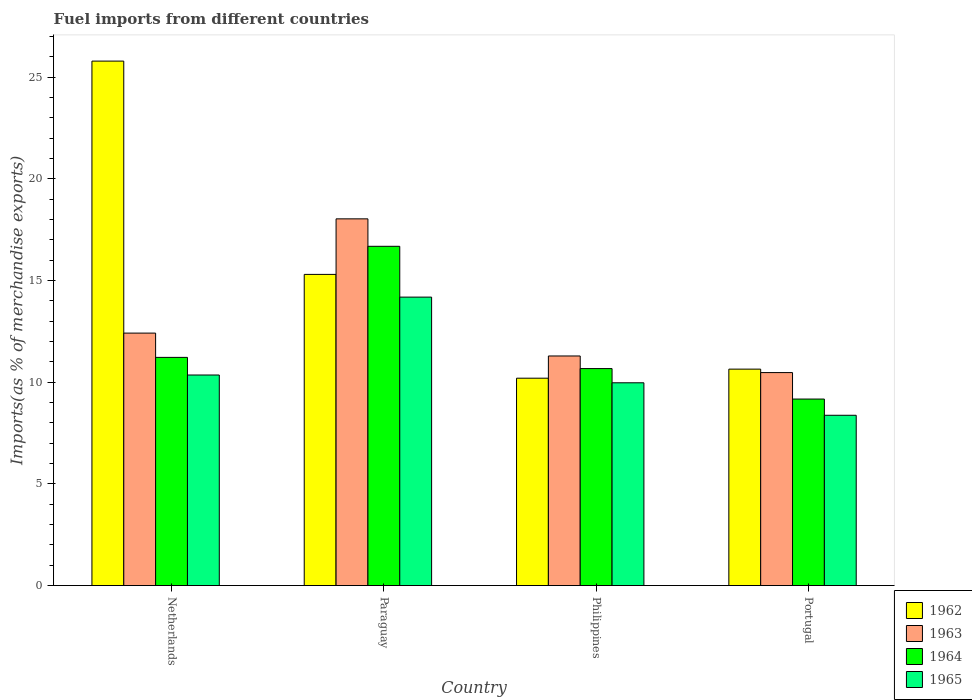How many different coloured bars are there?
Provide a succinct answer. 4. Are the number of bars on each tick of the X-axis equal?
Ensure brevity in your answer.  Yes. How many bars are there on the 3rd tick from the left?
Your answer should be very brief. 4. How many bars are there on the 1st tick from the right?
Offer a very short reply. 4. What is the label of the 4th group of bars from the left?
Make the answer very short. Portugal. What is the percentage of imports to different countries in 1965 in Paraguay?
Give a very brief answer. 14.18. Across all countries, what is the maximum percentage of imports to different countries in 1964?
Your answer should be very brief. 16.68. Across all countries, what is the minimum percentage of imports to different countries in 1963?
Offer a very short reply. 10.47. In which country was the percentage of imports to different countries in 1965 maximum?
Your response must be concise. Paraguay. What is the total percentage of imports to different countries in 1962 in the graph?
Offer a terse response. 61.92. What is the difference between the percentage of imports to different countries in 1962 in Philippines and that in Portugal?
Provide a succinct answer. -0.45. What is the difference between the percentage of imports to different countries in 1964 in Netherlands and the percentage of imports to different countries in 1962 in Portugal?
Ensure brevity in your answer.  0.58. What is the average percentage of imports to different countries in 1964 per country?
Offer a terse response. 11.93. What is the difference between the percentage of imports to different countries of/in 1962 and percentage of imports to different countries of/in 1963 in Philippines?
Your answer should be very brief. -1.09. What is the ratio of the percentage of imports to different countries in 1965 in Paraguay to that in Philippines?
Give a very brief answer. 1.42. Is the difference between the percentage of imports to different countries in 1962 in Philippines and Portugal greater than the difference between the percentage of imports to different countries in 1963 in Philippines and Portugal?
Give a very brief answer. No. What is the difference between the highest and the second highest percentage of imports to different countries in 1964?
Provide a succinct answer. 6.01. What is the difference between the highest and the lowest percentage of imports to different countries in 1963?
Offer a very short reply. 7.56. In how many countries, is the percentage of imports to different countries in 1963 greater than the average percentage of imports to different countries in 1963 taken over all countries?
Make the answer very short. 1. Is it the case that in every country, the sum of the percentage of imports to different countries in 1963 and percentage of imports to different countries in 1964 is greater than the sum of percentage of imports to different countries in 1962 and percentage of imports to different countries in 1965?
Give a very brief answer. No. What does the 3rd bar from the left in Paraguay represents?
Your response must be concise. 1964. Is it the case that in every country, the sum of the percentage of imports to different countries in 1962 and percentage of imports to different countries in 1964 is greater than the percentage of imports to different countries in 1963?
Give a very brief answer. Yes. How many bars are there?
Give a very brief answer. 16. How many countries are there in the graph?
Offer a terse response. 4. What is the difference between two consecutive major ticks on the Y-axis?
Ensure brevity in your answer.  5. Where does the legend appear in the graph?
Make the answer very short. Bottom right. How are the legend labels stacked?
Ensure brevity in your answer.  Vertical. What is the title of the graph?
Your response must be concise. Fuel imports from different countries. What is the label or title of the Y-axis?
Your answer should be very brief. Imports(as % of merchandise exports). What is the Imports(as % of merchandise exports) of 1962 in Netherlands?
Your answer should be compact. 25.79. What is the Imports(as % of merchandise exports) in 1963 in Netherlands?
Your response must be concise. 12.41. What is the Imports(as % of merchandise exports) of 1964 in Netherlands?
Give a very brief answer. 11.22. What is the Imports(as % of merchandise exports) in 1965 in Netherlands?
Keep it short and to the point. 10.35. What is the Imports(as % of merchandise exports) of 1962 in Paraguay?
Make the answer very short. 15.3. What is the Imports(as % of merchandise exports) of 1963 in Paraguay?
Keep it short and to the point. 18.03. What is the Imports(as % of merchandise exports) in 1964 in Paraguay?
Your answer should be very brief. 16.68. What is the Imports(as % of merchandise exports) of 1965 in Paraguay?
Offer a terse response. 14.18. What is the Imports(as % of merchandise exports) in 1962 in Philippines?
Your response must be concise. 10.2. What is the Imports(as % of merchandise exports) of 1963 in Philippines?
Give a very brief answer. 11.29. What is the Imports(as % of merchandise exports) in 1964 in Philippines?
Provide a short and direct response. 10.67. What is the Imports(as % of merchandise exports) in 1965 in Philippines?
Your answer should be very brief. 9.97. What is the Imports(as % of merchandise exports) of 1962 in Portugal?
Your answer should be very brief. 10.64. What is the Imports(as % of merchandise exports) of 1963 in Portugal?
Provide a short and direct response. 10.47. What is the Imports(as % of merchandise exports) of 1964 in Portugal?
Ensure brevity in your answer.  9.17. What is the Imports(as % of merchandise exports) in 1965 in Portugal?
Your answer should be very brief. 8.37. Across all countries, what is the maximum Imports(as % of merchandise exports) of 1962?
Keep it short and to the point. 25.79. Across all countries, what is the maximum Imports(as % of merchandise exports) of 1963?
Make the answer very short. 18.03. Across all countries, what is the maximum Imports(as % of merchandise exports) of 1964?
Offer a very short reply. 16.68. Across all countries, what is the maximum Imports(as % of merchandise exports) in 1965?
Provide a short and direct response. 14.18. Across all countries, what is the minimum Imports(as % of merchandise exports) of 1962?
Your answer should be very brief. 10.2. Across all countries, what is the minimum Imports(as % of merchandise exports) of 1963?
Your response must be concise. 10.47. Across all countries, what is the minimum Imports(as % of merchandise exports) of 1964?
Provide a succinct answer. 9.17. Across all countries, what is the minimum Imports(as % of merchandise exports) in 1965?
Keep it short and to the point. 8.37. What is the total Imports(as % of merchandise exports) of 1962 in the graph?
Provide a succinct answer. 61.92. What is the total Imports(as % of merchandise exports) in 1963 in the graph?
Provide a succinct answer. 52.2. What is the total Imports(as % of merchandise exports) of 1964 in the graph?
Keep it short and to the point. 47.74. What is the total Imports(as % of merchandise exports) of 1965 in the graph?
Make the answer very short. 42.88. What is the difference between the Imports(as % of merchandise exports) in 1962 in Netherlands and that in Paraguay?
Ensure brevity in your answer.  10.49. What is the difference between the Imports(as % of merchandise exports) in 1963 in Netherlands and that in Paraguay?
Offer a terse response. -5.62. What is the difference between the Imports(as % of merchandise exports) in 1964 in Netherlands and that in Paraguay?
Provide a succinct answer. -5.46. What is the difference between the Imports(as % of merchandise exports) in 1965 in Netherlands and that in Paraguay?
Provide a short and direct response. -3.83. What is the difference between the Imports(as % of merchandise exports) of 1962 in Netherlands and that in Philippines?
Provide a short and direct response. 15.59. What is the difference between the Imports(as % of merchandise exports) of 1963 in Netherlands and that in Philippines?
Ensure brevity in your answer.  1.12. What is the difference between the Imports(as % of merchandise exports) of 1964 in Netherlands and that in Philippines?
Provide a short and direct response. 0.55. What is the difference between the Imports(as % of merchandise exports) of 1965 in Netherlands and that in Philippines?
Offer a terse response. 0.38. What is the difference between the Imports(as % of merchandise exports) in 1962 in Netherlands and that in Portugal?
Offer a very short reply. 15.15. What is the difference between the Imports(as % of merchandise exports) in 1963 in Netherlands and that in Portugal?
Keep it short and to the point. 1.94. What is the difference between the Imports(as % of merchandise exports) of 1964 in Netherlands and that in Portugal?
Ensure brevity in your answer.  2.05. What is the difference between the Imports(as % of merchandise exports) of 1965 in Netherlands and that in Portugal?
Keep it short and to the point. 1.98. What is the difference between the Imports(as % of merchandise exports) of 1962 in Paraguay and that in Philippines?
Provide a short and direct response. 5.1. What is the difference between the Imports(as % of merchandise exports) of 1963 in Paraguay and that in Philippines?
Your answer should be compact. 6.74. What is the difference between the Imports(as % of merchandise exports) of 1964 in Paraguay and that in Philippines?
Provide a succinct answer. 6.01. What is the difference between the Imports(as % of merchandise exports) of 1965 in Paraguay and that in Philippines?
Provide a short and direct response. 4.21. What is the difference between the Imports(as % of merchandise exports) of 1962 in Paraguay and that in Portugal?
Your answer should be very brief. 4.66. What is the difference between the Imports(as % of merchandise exports) in 1963 in Paraguay and that in Portugal?
Keep it short and to the point. 7.56. What is the difference between the Imports(as % of merchandise exports) of 1964 in Paraguay and that in Portugal?
Make the answer very short. 7.51. What is the difference between the Imports(as % of merchandise exports) in 1965 in Paraguay and that in Portugal?
Keep it short and to the point. 5.81. What is the difference between the Imports(as % of merchandise exports) in 1962 in Philippines and that in Portugal?
Provide a succinct answer. -0.45. What is the difference between the Imports(as % of merchandise exports) in 1963 in Philippines and that in Portugal?
Your response must be concise. 0.82. What is the difference between the Imports(as % of merchandise exports) in 1964 in Philippines and that in Portugal?
Keep it short and to the point. 1.5. What is the difference between the Imports(as % of merchandise exports) of 1965 in Philippines and that in Portugal?
Ensure brevity in your answer.  1.6. What is the difference between the Imports(as % of merchandise exports) of 1962 in Netherlands and the Imports(as % of merchandise exports) of 1963 in Paraguay?
Make the answer very short. 7.76. What is the difference between the Imports(as % of merchandise exports) in 1962 in Netherlands and the Imports(as % of merchandise exports) in 1964 in Paraguay?
Make the answer very short. 9.11. What is the difference between the Imports(as % of merchandise exports) in 1962 in Netherlands and the Imports(as % of merchandise exports) in 1965 in Paraguay?
Your answer should be very brief. 11.6. What is the difference between the Imports(as % of merchandise exports) of 1963 in Netherlands and the Imports(as % of merchandise exports) of 1964 in Paraguay?
Your answer should be compact. -4.27. What is the difference between the Imports(as % of merchandise exports) of 1963 in Netherlands and the Imports(as % of merchandise exports) of 1965 in Paraguay?
Your response must be concise. -1.77. What is the difference between the Imports(as % of merchandise exports) of 1964 in Netherlands and the Imports(as % of merchandise exports) of 1965 in Paraguay?
Provide a short and direct response. -2.96. What is the difference between the Imports(as % of merchandise exports) in 1962 in Netherlands and the Imports(as % of merchandise exports) in 1963 in Philippines?
Your response must be concise. 14.5. What is the difference between the Imports(as % of merchandise exports) in 1962 in Netherlands and the Imports(as % of merchandise exports) in 1964 in Philippines?
Keep it short and to the point. 15.12. What is the difference between the Imports(as % of merchandise exports) of 1962 in Netherlands and the Imports(as % of merchandise exports) of 1965 in Philippines?
Make the answer very short. 15.82. What is the difference between the Imports(as % of merchandise exports) of 1963 in Netherlands and the Imports(as % of merchandise exports) of 1964 in Philippines?
Your response must be concise. 1.74. What is the difference between the Imports(as % of merchandise exports) of 1963 in Netherlands and the Imports(as % of merchandise exports) of 1965 in Philippines?
Make the answer very short. 2.44. What is the difference between the Imports(as % of merchandise exports) in 1964 in Netherlands and the Imports(as % of merchandise exports) in 1965 in Philippines?
Make the answer very short. 1.25. What is the difference between the Imports(as % of merchandise exports) of 1962 in Netherlands and the Imports(as % of merchandise exports) of 1963 in Portugal?
Ensure brevity in your answer.  15.32. What is the difference between the Imports(as % of merchandise exports) of 1962 in Netherlands and the Imports(as % of merchandise exports) of 1964 in Portugal?
Offer a very short reply. 16.62. What is the difference between the Imports(as % of merchandise exports) of 1962 in Netherlands and the Imports(as % of merchandise exports) of 1965 in Portugal?
Your answer should be compact. 17.41. What is the difference between the Imports(as % of merchandise exports) of 1963 in Netherlands and the Imports(as % of merchandise exports) of 1964 in Portugal?
Your response must be concise. 3.24. What is the difference between the Imports(as % of merchandise exports) of 1963 in Netherlands and the Imports(as % of merchandise exports) of 1965 in Portugal?
Your response must be concise. 4.04. What is the difference between the Imports(as % of merchandise exports) in 1964 in Netherlands and the Imports(as % of merchandise exports) in 1965 in Portugal?
Your answer should be compact. 2.85. What is the difference between the Imports(as % of merchandise exports) of 1962 in Paraguay and the Imports(as % of merchandise exports) of 1963 in Philippines?
Keep it short and to the point. 4.01. What is the difference between the Imports(as % of merchandise exports) in 1962 in Paraguay and the Imports(as % of merchandise exports) in 1964 in Philippines?
Make the answer very short. 4.63. What is the difference between the Imports(as % of merchandise exports) in 1962 in Paraguay and the Imports(as % of merchandise exports) in 1965 in Philippines?
Your answer should be very brief. 5.33. What is the difference between the Imports(as % of merchandise exports) in 1963 in Paraguay and the Imports(as % of merchandise exports) in 1964 in Philippines?
Your response must be concise. 7.36. What is the difference between the Imports(as % of merchandise exports) in 1963 in Paraguay and the Imports(as % of merchandise exports) in 1965 in Philippines?
Keep it short and to the point. 8.06. What is the difference between the Imports(as % of merchandise exports) of 1964 in Paraguay and the Imports(as % of merchandise exports) of 1965 in Philippines?
Give a very brief answer. 6.71. What is the difference between the Imports(as % of merchandise exports) of 1962 in Paraguay and the Imports(as % of merchandise exports) of 1963 in Portugal?
Your answer should be compact. 4.83. What is the difference between the Imports(as % of merchandise exports) of 1962 in Paraguay and the Imports(as % of merchandise exports) of 1964 in Portugal?
Offer a terse response. 6.13. What is the difference between the Imports(as % of merchandise exports) in 1962 in Paraguay and the Imports(as % of merchandise exports) in 1965 in Portugal?
Your response must be concise. 6.93. What is the difference between the Imports(as % of merchandise exports) of 1963 in Paraguay and the Imports(as % of merchandise exports) of 1964 in Portugal?
Keep it short and to the point. 8.86. What is the difference between the Imports(as % of merchandise exports) of 1963 in Paraguay and the Imports(as % of merchandise exports) of 1965 in Portugal?
Offer a very short reply. 9.66. What is the difference between the Imports(as % of merchandise exports) in 1964 in Paraguay and the Imports(as % of merchandise exports) in 1965 in Portugal?
Provide a short and direct response. 8.31. What is the difference between the Imports(as % of merchandise exports) of 1962 in Philippines and the Imports(as % of merchandise exports) of 1963 in Portugal?
Your response must be concise. -0.28. What is the difference between the Imports(as % of merchandise exports) in 1962 in Philippines and the Imports(as % of merchandise exports) in 1964 in Portugal?
Provide a succinct answer. 1.03. What is the difference between the Imports(as % of merchandise exports) of 1962 in Philippines and the Imports(as % of merchandise exports) of 1965 in Portugal?
Provide a short and direct response. 1.82. What is the difference between the Imports(as % of merchandise exports) in 1963 in Philippines and the Imports(as % of merchandise exports) in 1964 in Portugal?
Offer a terse response. 2.12. What is the difference between the Imports(as % of merchandise exports) in 1963 in Philippines and the Imports(as % of merchandise exports) in 1965 in Portugal?
Your response must be concise. 2.92. What is the difference between the Imports(as % of merchandise exports) in 1964 in Philippines and the Imports(as % of merchandise exports) in 1965 in Portugal?
Your response must be concise. 2.3. What is the average Imports(as % of merchandise exports) of 1962 per country?
Provide a succinct answer. 15.48. What is the average Imports(as % of merchandise exports) in 1963 per country?
Provide a short and direct response. 13.05. What is the average Imports(as % of merchandise exports) of 1964 per country?
Your answer should be compact. 11.94. What is the average Imports(as % of merchandise exports) of 1965 per country?
Provide a short and direct response. 10.72. What is the difference between the Imports(as % of merchandise exports) in 1962 and Imports(as % of merchandise exports) in 1963 in Netherlands?
Ensure brevity in your answer.  13.37. What is the difference between the Imports(as % of merchandise exports) in 1962 and Imports(as % of merchandise exports) in 1964 in Netherlands?
Provide a succinct answer. 14.57. What is the difference between the Imports(as % of merchandise exports) of 1962 and Imports(as % of merchandise exports) of 1965 in Netherlands?
Offer a very short reply. 15.43. What is the difference between the Imports(as % of merchandise exports) in 1963 and Imports(as % of merchandise exports) in 1964 in Netherlands?
Provide a succinct answer. 1.19. What is the difference between the Imports(as % of merchandise exports) in 1963 and Imports(as % of merchandise exports) in 1965 in Netherlands?
Provide a succinct answer. 2.06. What is the difference between the Imports(as % of merchandise exports) in 1964 and Imports(as % of merchandise exports) in 1965 in Netherlands?
Your answer should be compact. 0.87. What is the difference between the Imports(as % of merchandise exports) in 1962 and Imports(as % of merchandise exports) in 1963 in Paraguay?
Provide a short and direct response. -2.73. What is the difference between the Imports(as % of merchandise exports) of 1962 and Imports(as % of merchandise exports) of 1964 in Paraguay?
Offer a very short reply. -1.38. What is the difference between the Imports(as % of merchandise exports) of 1962 and Imports(as % of merchandise exports) of 1965 in Paraguay?
Your response must be concise. 1.12. What is the difference between the Imports(as % of merchandise exports) of 1963 and Imports(as % of merchandise exports) of 1964 in Paraguay?
Your answer should be very brief. 1.35. What is the difference between the Imports(as % of merchandise exports) of 1963 and Imports(as % of merchandise exports) of 1965 in Paraguay?
Ensure brevity in your answer.  3.85. What is the difference between the Imports(as % of merchandise exports) of 1964 and Imports(as % of merchandise exports) of 1965 in Paraguay?
Offer a very short reply. 2.5. What is the difference between the Imports(as % of merchandise exports) in 1962 and Imports(as % of merchandise exports) in 1963 in Philippines?
Ensure brevity in your answer.  -1.09. What is the difference between the Imports(as % of merchandise exports) in 1962 and Imports(as % of merchandise exports) in 1964 in Philippines?
Keep it short and to the point. -0.47. What is the difference between the Imports(as % of merchandise exports) of 1962 and Imports(as % of merchandise exports) of 1965 in Philippines?
Offer a very short reply. 0.23. What is the difference between the Imports(as % of merchandise exports) of 1963 and Imports(as % of merchandise exports) of 1964 in Philippines?
Your answer should be very brief. 0.62. What is the difference between the Imports(as % of merchandise exports) in 1963 and Imports(as % of merchandise exports) in 1965 in Philippines?
Offer a terse response. 1.32. What is the difference between the Imports(as % of merchandise exports) of 1964 and Imports(as % of merchandise exports) of 1965 in Philippines?
Your answer should be very brief. 0.7. What is the difference between the Imports(as % of merchandise exports) of 1962 and Imports(as % of merchandise exports) of 1963 in Portugal?
Your answer should be compact. 0.17. What is the difference between the Imports(as % of merchandise exports) of 1962 and Imports(as % of merchandise exports) of 1964 in Portugal?
Your response must be concise. 1.47. What is the difference between the Imports(as % of merchandise exports) in 1962 and Imports(as % of merchandise exports) in 1965 in Portugal?
Your answer should be very brief. 2.27. What is the difference between the Imports(as % of merchandise exports) of 1963 and Imports(as % of merchandise exports) of 1964 in Portugal?
Keep it short and to the point. 1.3. What is the difference between the Imports(as % of merchandise exports) of 1963 and Imports(as % of merchandise exports) of 1965 in Portugal?
Provide a succinct answer. 2.1. What is the difference between the Imports(as % of merchandise exports) in 1964 and Imports(as % of merchandise exports) in 1965 in Portugal?
Offer a terse response. 0.8. What is the ratio of the Imports(as % of merchandise exports) of 1962 in Netherlands to that in Paraguay?
Provide a short and direct response. 1.69. What is the ratio of the Imports(as % of merchandise exports) of 1963 in Netherlands to that in Paraguay?
Provide a succinct answer. 0.69. What is the ratio of the Imports(as % of merchandise exports) of 1964 in Netherlands to that in Paraguay?
Ensure brevity in your answer.  0.67. What is the ratio of the Imports(as % of merchandise exports) in 1965 in Netherlands to that in Paraguay?
Keep it short and to the point. 0.73. What is the ratio of the Imports(as % of merchandise exports) of 1962 in Netherlands to that in Philippines?
Provide a succinct answer. 2.53. What is the ratio of the Imports(as % of merchandise exports) in 1963 in Netherlands to that in Philippines?
Make the answer very short. 1.1. What is the ratio of the Imports(as % of merchandise exports) of 1964 in Netherlands to that in Philippines?
Your answer should be compact. 1.05. What is the ratio of the Imports(as % of merchandise exports) of 1965 in Netherlands to that in Philippines?
Your answer should be compact. 1.04. What is the ratio of the Imports(as % of merchandise exports) of 1962 in Netherlands to that in Portugal?
Ensure brevity in your answer.  2.42. What is the ratio of the Imports(as % of merchandise exports) in 1963 in Netherlands to that in Portugal?
Keep it short and to the point. 1.19. What is the ratio of the Imports(as % of merchandise exports) in 1964 in Netherlands to that in Portugal?
Your response must be concise. 1.22. What is the ratio of the Imports(as % of merchandise exports) in 1965 in Netherlands to that in Portugal?
Your answer should be very brief. 1.24. What is the ratio of the Imports(as % of merchandise exports) of 1962 in Paraguay to that in Philippines?
Your answer should be compact. 1.5. What is the ratio of the Imports(as % of merchandise exports) of 1963 in Paraguay to that in Philippines?
Keep it short and to the point. 1.6. What is the ratio of the Imports(as % of merchandise exports) of 1964 in Paraguay to that in Philippines?
Make the answer very short. 1.56. What is the ratio of the Imports(as % of merchandise exports) of 1965 in Paraguay to that in Philippines?
Make the answer very short. 1.42. What is the ratio of the Imports(as % of merchandise exports) of 1962 in Paraguay to that in Portugal?
Your answer should be compact. 1.44. What is the ratio of the Imports(as % of merchandise exports) of 1963 in Paraguay to that in Portugal?
Make the answer very short. 1.72. What is the ratio of the Imports(as % of merchandise exports) of 1964 in Paraguay to that in Portugal?
Ensure brevity in your answer.  1.82. What is the ratio of the Imports(as % of merchandise exports) in 1965 in Paraguay to that in Portugal?
Offer a very short reply. 1.69. What is the ratio of the Imports(as % of merchandise exports) of 1962 in Philippines to that in Portugal?
Offer a terse response. 0.96. What is the ratio of the Imports(as % of merchandise exports) of 1963 in Philippines to that in Portugal?
Offer a terse response. 1.08. What is the ratio of the Imports(as % of merchandise exports) of 1964 in Philippines to that in Portugal?
Ensure brevity in your answer.  1.16. What is the ratio of the Imports(as % of merchandise exports) of 1965 in Philippines to that in Portugal?
Offer a very short reply. 1.19. What is the difference between the highest and the second highest Imports(as % of merchandise exports) of 1962?
Your response must be concise. 10.49. What is the difference between the highest and the second highest Imports(as % of merchandise exports) of 1963?
Your answer should be compact. 5.62. What is the difference between the highest and the second highest Imports(as % of merchandise exports) in 1964?
Offer a terse response. 5.46. What is the difference between the highest and the second highest Imports(as % of merchandise exports) in 1965?
Ensure brevity in your answer.  3.83. What is the difference between the highest and the lowest Imports(as % of merchandise exports) of 1962?
Ensure brevity in your answer.  15.59. What is the difference between the highest and the lowest Imports(as % of merchandise exports) of 1963?
Offer a very short reply. 7.56. What is the difference between the highest and the lowest Imports(as % of merchandise exports) of 1964?
Offer a very short reply. 7.51. What is the difference between the highest and the lowest Imports(as % of merchandise exports) of 1965?
Give a very brief answer. 5.81. 